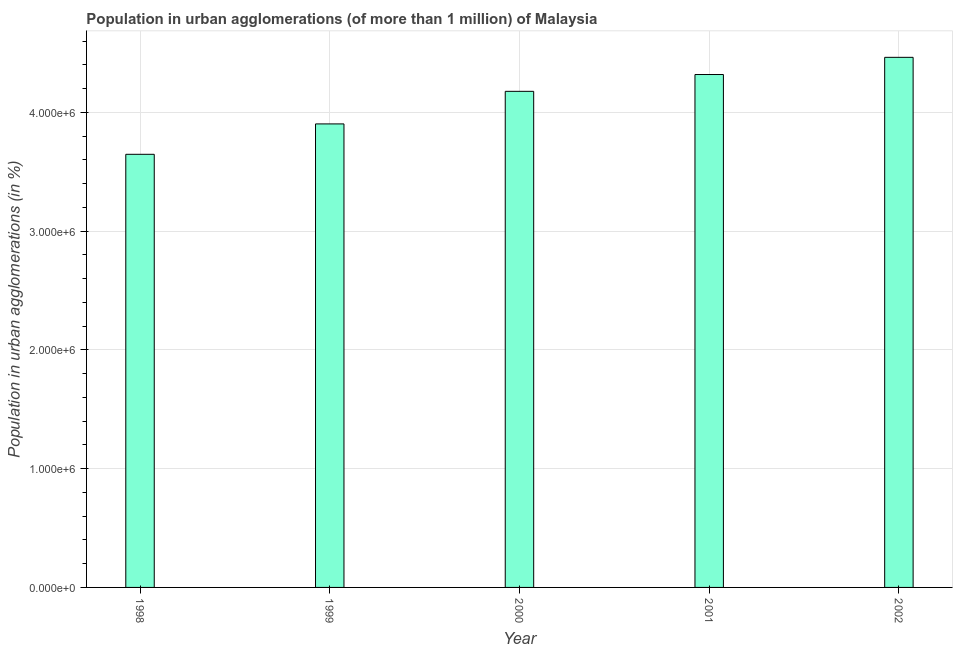Does the graph contain any zero values?
Provide a short and direct response. No. Does the graph contain grids?
Provide a short and direct response. Yes. What is the title of the graph?
Offer a very short reply. Population in urban agglomerations (of more than 1 million) of Malaysia. What is the label or title of the X-axis?
Provide a succinct answer. Year. What is the label or title of the Y-axis?
Make the answer very short. Population in urban agglomerations (in %). What is the population in urban agglomerations in 2002?
Keep it short and to the point. 4.46e+06. Across all years, what is the maximum population in urban agglomerations?
Give a very brief answer. 4.46e+06. Across all years, what is the minimum population in urban agglomerations?
Offer a terse response. 3.65e+06. In which year was the population in urban agglomerations minimum?
Your answer should be very brief. 1998. What is the sum of the population in urban agglomerations?
Provide a succinct answer. 2.05e+07. What is the difference between the population in urban agglomerations in 1998 and 2000?
Offer a very short reply. -5.30e+05. What is the average population in urban agglomerations per year?
Offer a terse response. 4.10e+06. What is the median population in urban agglomerations?
Ensure brevity in your answer.  4.18e+06. What is the ratio of the population in urban agglomerations in 1999 to that in 2002?
Keep it short and to the point. 0.87. Is the population in urban agglomerations in 1999 less than that in 2000?
Give a very brief answer. Yes. What is the difference between the highest and the second highest population in urban agglomerations?
Make the answer very short. 1.45e+05. What is the difference between the highest and the lowest population in urban agglomerations?
Make the answer very short. 8.16e+05. What is the difference between two consecutive major ticks on the Y-axis?
Ensure brevity in your answer.  1.00e+06. Are the values on the major ticks of Y-axis written in scientific E-notation?
Provide a short and direct response. Yes. What is the Population in urban agglomerations (in %) of 1998?
Your answer should be compact. 3.65e+06. What is the Population in urban agglomerations (in %) of 1999?
Your response must be concise. 3.90e+06. What is the Population in urban agglomerations (in %) in 2000?
Your answer should be compact. 4.18e+06. What is the Population in urban agglomerations (in %) in 2001?
Offer a very short reply. 4.32e+06. What is the Population in urban agglomerations (in %) in 2002?
Keep it short and to the point. 4.46e+06. What is the difference between the Population in urban agglomerations (in %) in 1998 and 1999?
Your answer should be compact. -2.56e+05. What is the difference between the Population in urban agglomerations (in %) in 1998 and 2000?
Your answer should be very brief. -5.30e+05. What is the difference between the Population in urban agglomerations (in %) in 1998 and 2001?
Provide a succinct answer. -6.72e+05. What is the difference between the Population in urban agglomerations (in %) in 1998 and 2002?
Offer a terse response. -8.16e+05. What is the difference between the Population in urban agglomerations (in %) in 1999 and 2000?
Your answer should be very brief. -2.74e+05. What is the difference between the Population in urban agglomerations (in %) in 1999 and 2001?
Give a very brief answer. -4.16e+05. What is the difference between the Population in urban agglomerations (in %) in 1999 and 2002?
Your answer should be compact. -5.60e+05. What is the difference between the Population in urban agglomerations (in %) in 2000 and 2001?
Give a very brief answer. -1.41e+05. What is the difference between the Population in urban agglomerations (in %) in 2000 and 2002?
Make the answer very short. -2.86e+05. What is the difference between the Population in urban agglomerations (in %) in 2001 and 2002?
Ensure brevity in your answer.  -1.45e+05. What is the ratio of the Population in urban agglomerations (in %) in 1998 to that in 1999?
Your response must be concise. 0.93. What is the ratio of the Population in urban agglomerations (in %) in 1998 to that in 2000?
Provide a succinct answer. 0.87. What is the ratio of the Population in urban agglomerations (in %) in 1998 to that in 2001?
Give a very brief answer. 0.84. What is the ratio of the Population in urban agglomerations (in %) in 1998 to that in 2002?
Give a very brief answer. 0.82. What is the ratio of the Population in urban agglomerations (in %) in 1999 to that in 2000?
Your response must be concise. 0.93. What is the ratio of the Population in urban agglomerations (in %) in 1999 to that in 2001?
Ensure brevity in your answer.  0.9. What is the ratio of the Population in urban agglomerations (in %) in 1999 to that in 2002?
Ensure brevity in your answer.  0.87. What is the ratio of the Population in urban agglomerations (in %) in 2000 to that in 2001?
Give a very brief answer. 0.97. What is the ratio of the Population in urban agglomerations (in %) in 2000 to that in 2002?
Your answer should be very brief. 0.94. What is the ratio of the Population in urban agglomerations (in %) in 2001 to that in 2002?
Make the answer very short. 0.97. 